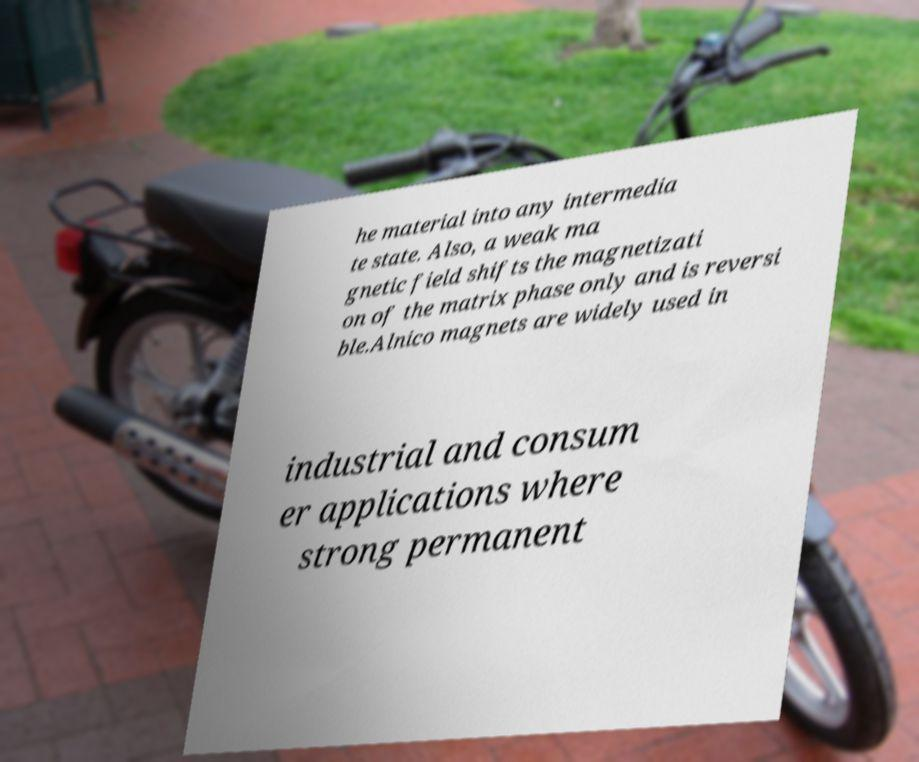Could you assist in decoding the text presented in this image and type it out clearly? he material into any intermedia te state. Also, a weak ma gnetic field shifts the magnetizati on of the matrix phase only and is reversi ble.Alnico magnets are widely used in industrial and consum er applications where strong permanent 